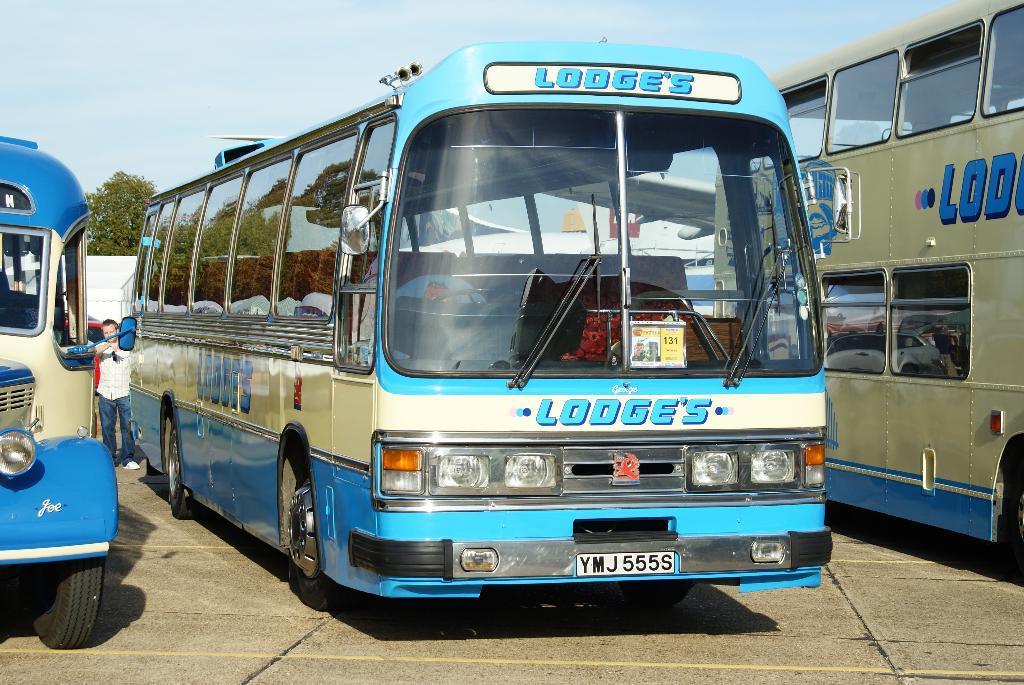Describe this image in one or two sentences. In the picture I can see some buses which are parked, there is a person wearing white color shirt, blue color pant standing near the bus and in the background of the picture there are some trees. 